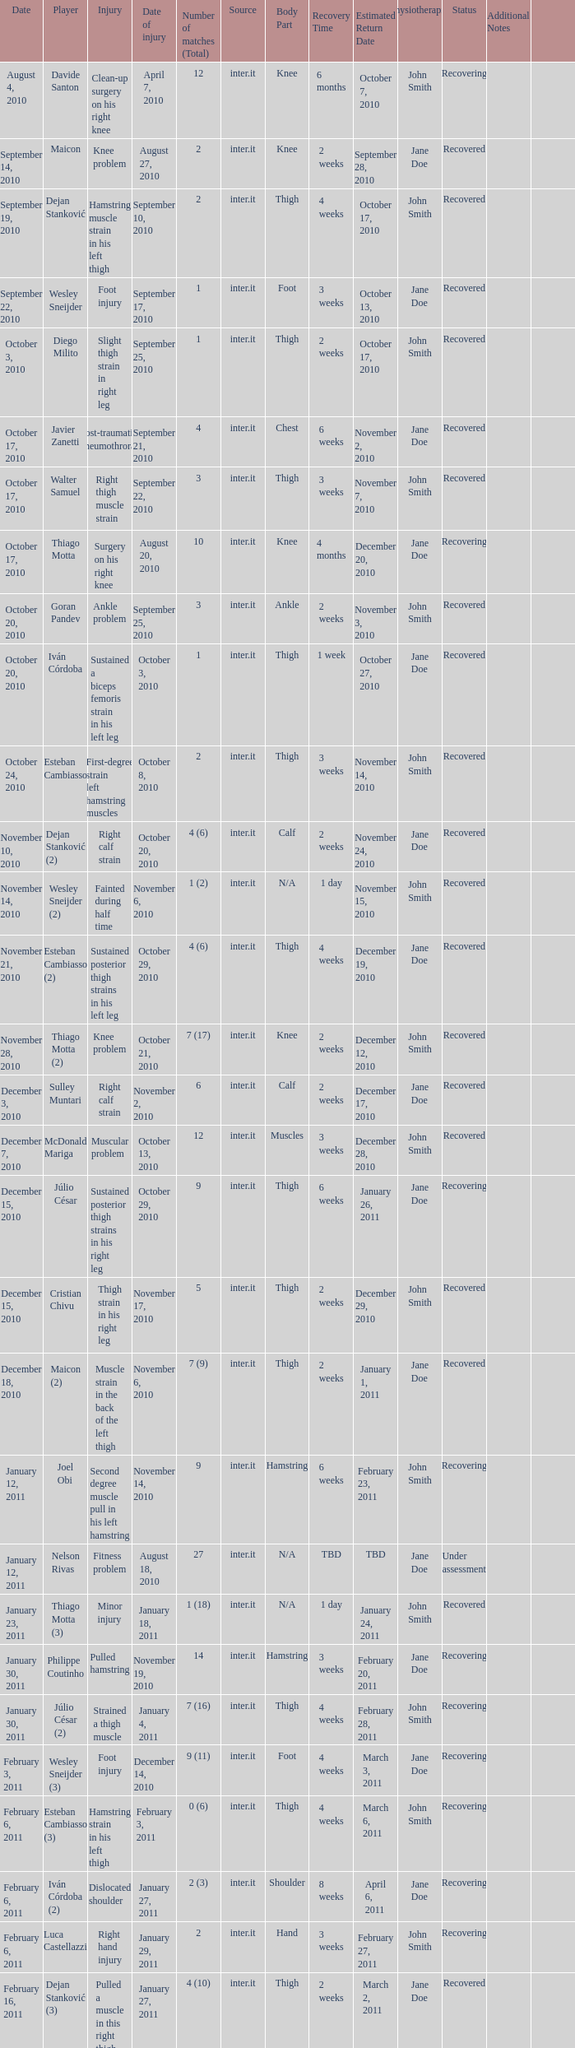What is the date of injury when the injury is sustained posterior thigh strains in his left leg? October 29, 2010. 